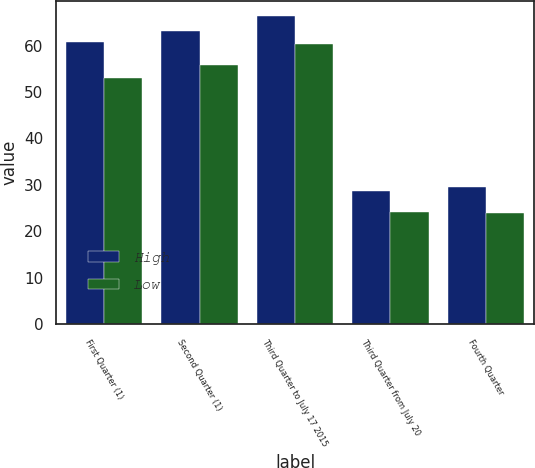<chart> <loc_0><loc_0><loc_500><loc_500><stacked_bar_chart><ecel><fcel>First Quarter (1)<fcel>Second Quarter (1)<fcel>Third Quarter to July 17 2015<fcel>Third Quarter from July 20<fcel>Fourth Quarter<nl><fcel>High<fcel>60.81<fcel>63.23<fcel>66.29<fcel>28.75<fcel>29.59<nl><fcel>Low<fcel>53<fcel>55.79<fcel>60.43<fcel>24.08<fcel>24<nl></chart> 